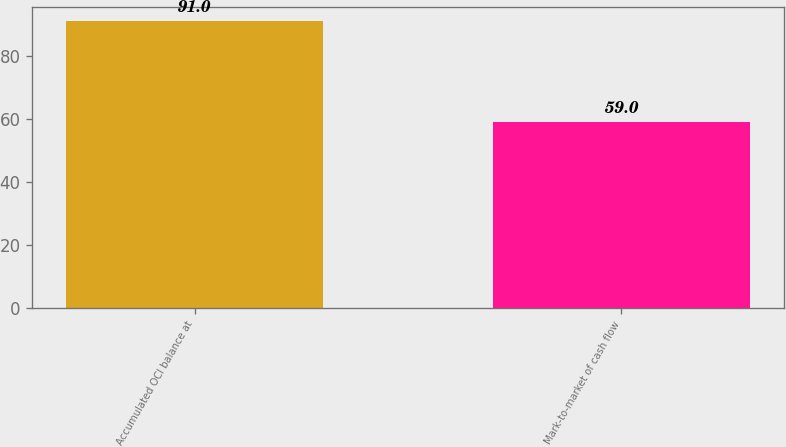Convert chart. <chart><loc_0><loc_0><loc_500><loc_500><bar_chart><fcel>Accumulated OCI balance at<fcel>Mark-to-market of cash flow<nl><fcel>91<fcel>59<nl></chart> 